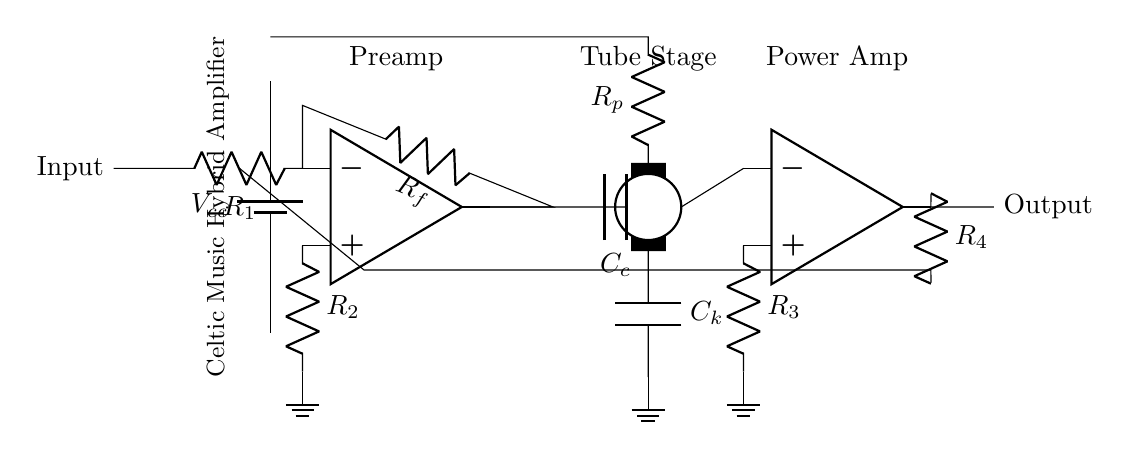What type of amplifier is used in this circuit? The circuit incorporates both operational amplifiers and a tube stage, indicating it is a hybrid amplifier. Operational amplifiers typically handle the initial amplification, while the tube adds warmth and richness to the sound, making it a hybrid design.
Answer: Hybrid amplifier What is the value represented by R1? The diagram shows an input resistor labeled as R1, but does not specify its value. In many circuits, it would usually be a few kilo-ohms, chosen based on the circuit design, to ensure appropriate signal level handling.
Answer: Not specified How many operational amplifiers are in this circuit? The circuit diagram clearly displays two operational amplifiers, one in the input stage and the other in the output stage. Each is represented by the op amp symbol, indicating their role in amplification.
Answer: Two What is the purpose of the feedback resistor R4? Resistor R4 is a feedback component that connects the output of the second op amp back to its inverting input, controlling the gain of the amplifier stage and stabilizing its operation. Feedback in amplifiers ensures linear operation and can affect bandwidth and frequency response.
Answer: Gain control What connects the output of the tube stage to the input of the second op amp? The output from the tube stage is directly connected to the inverting input of the second operational amplifier, facilitating the transfer of amplified signal ready for further processing or output. The connection is essential for continued amplification.
Answer: Direct connection What is the role of capacitor Cc in the circuit? Capacitor Cc couples the signal from the first operational amplifier to the tube stage while blocking any direct current offset, ensuring that only the alternating current (AC) component of the signal passes on for further processing in the tube stage. This is crucial for preserving audio quality.
Answer: AC coupling 